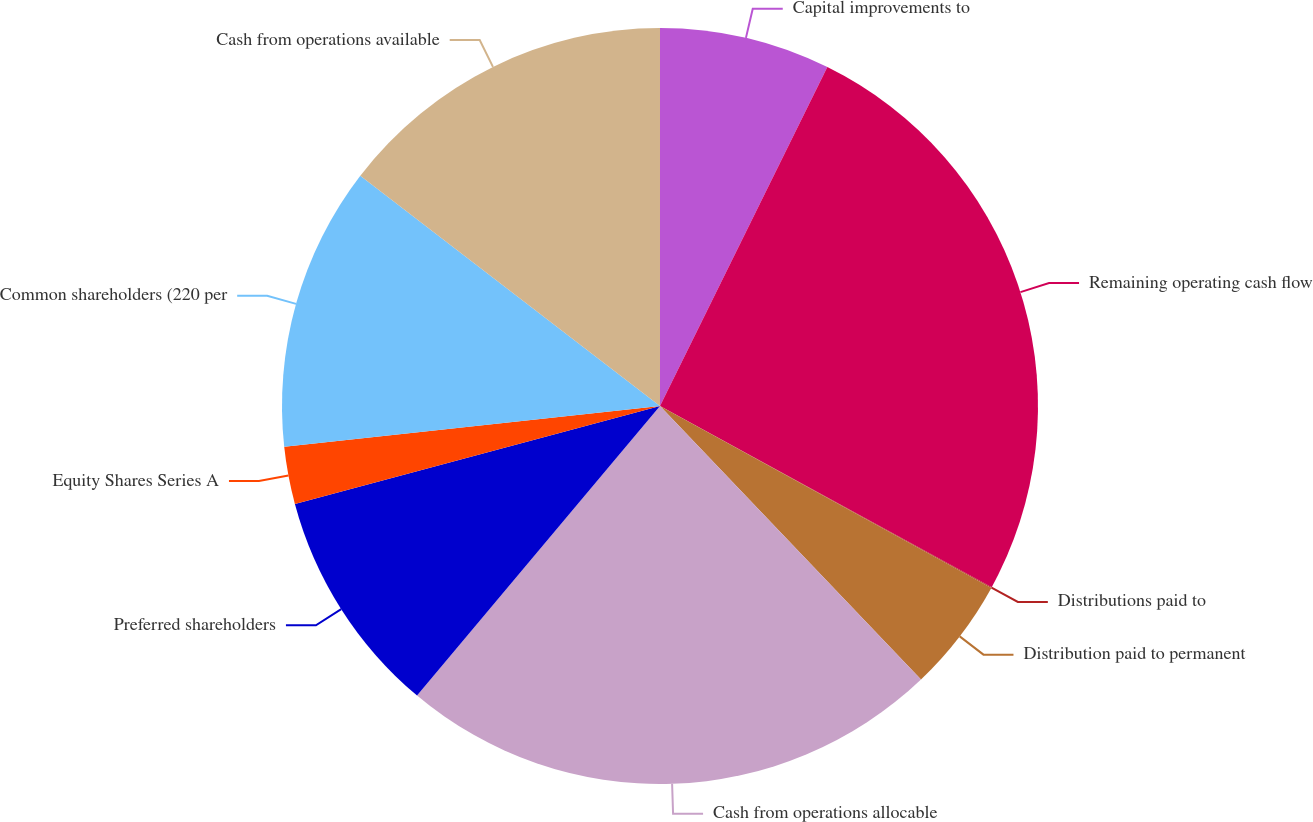<chart> <loc_0><loc_0><loc_500><loc_500><pie_chart><fcel>Capital improvements to<fcel>Remaining operating cash flow<fcel>Distributions paid to<fcel>Distribution paid to permanent<fcel>Cash from operations allocable<fcel>Preferred shareholders<fcel>Equity Shares Series A<fcel>Common shareholders (220 per<fcel>Cash from operations available<nl><fcel>7.3%<fcel>25.66%<fcel>0.03%<fcel>4.88%<fcel>23.24%<fcel>9.72%<fcel>2.45%<fcel>12.15%<fcel>14.57%<nl></chart> 